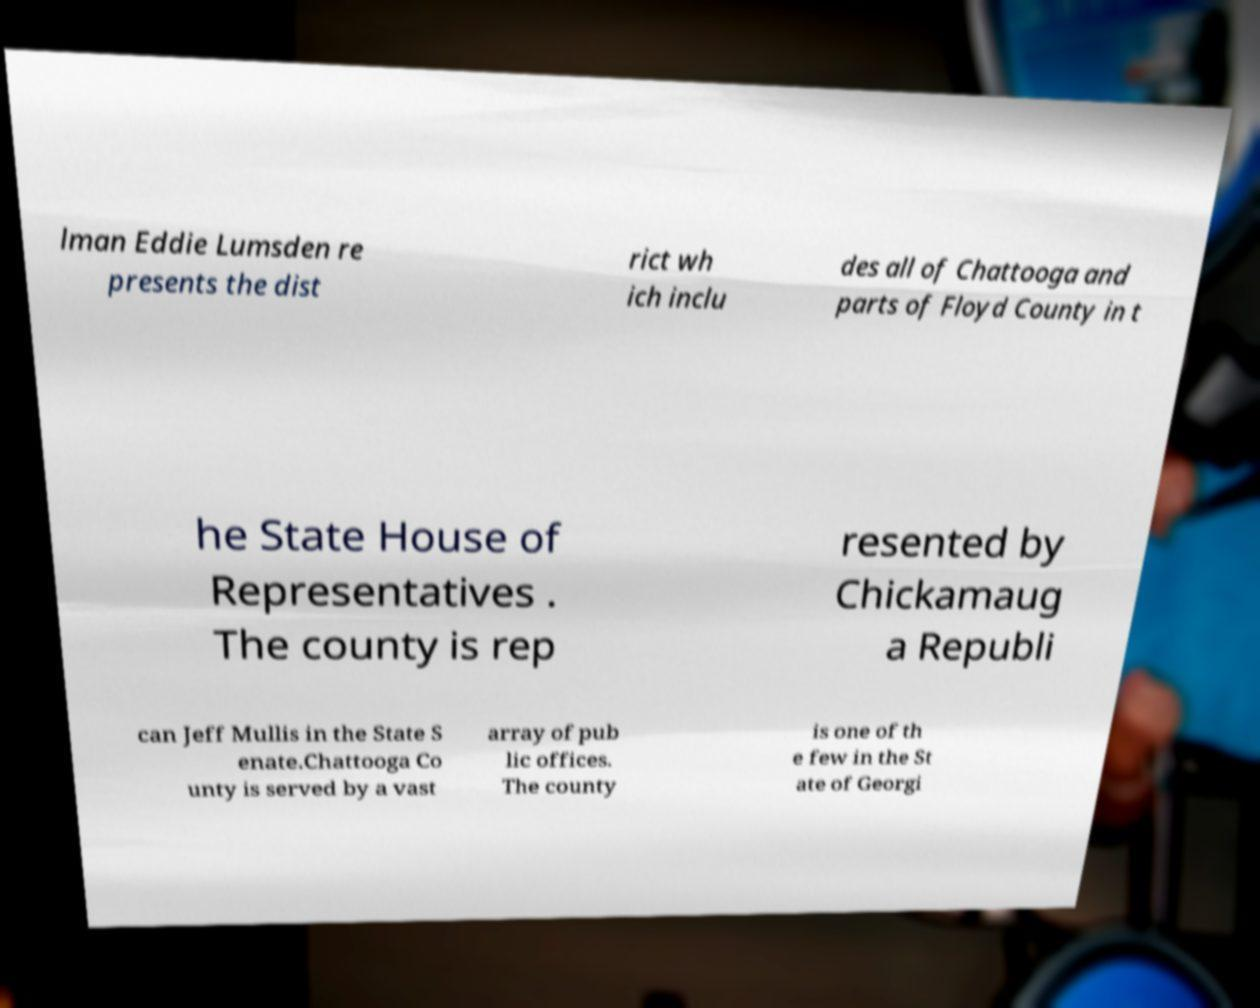Can you read and provide the text displayed in the image?This photo seems to have some interesting text. Can you extract and type it out for me? lman Eddie Lumsden re presents the dist rict wh ich inclu des all of Chattooga and parts of Floyd County in t he State House of Representatives . The county is rep resented by Chickamaug a Republi can Jeff Mullis in the State S enate.Chattooga Co unty is served by a vast array of pub lic offices. The county is one of th e few in the St ate of Georgi 